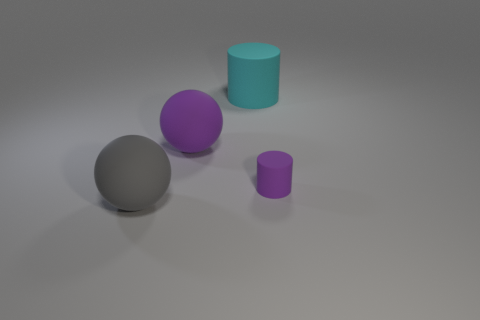What is the texture of the objects and does it affect the way light interacts with them? The objects have a matte texture, which scatters light in different directions, giving them a smooth and non-reflective appearance. This contrasts with a shiny surface, where light would be reflected in a more focused, specular manner. 